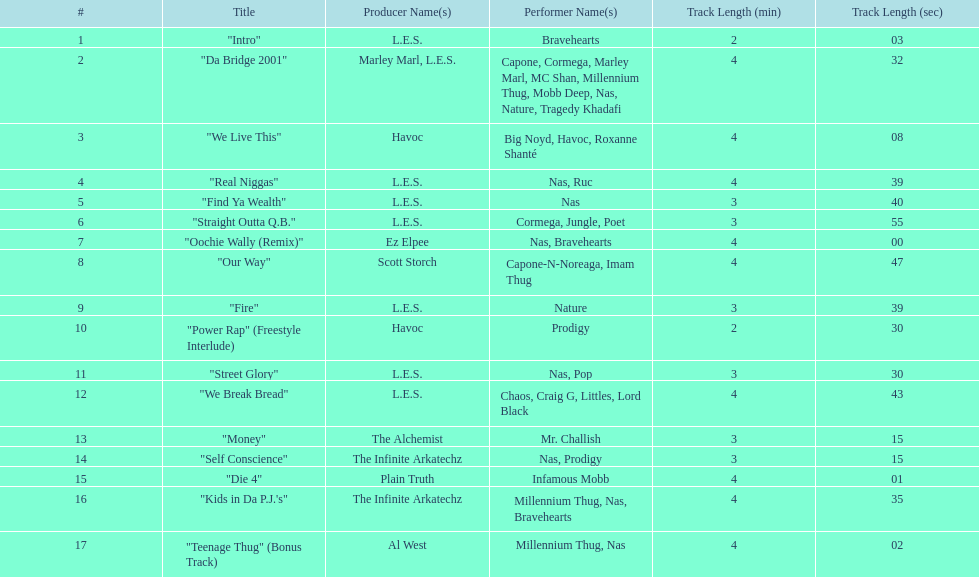What are the track lengths on the album? 2:03, 4:32, 4:08, 4:39, 3:40, 3:55, 4:00, 4:47, 3:39, 2:30, 3:30, 4:43, 3:15, 3:15, 4:01, 4:35, 4:02. What is the longest length? 4:47. 